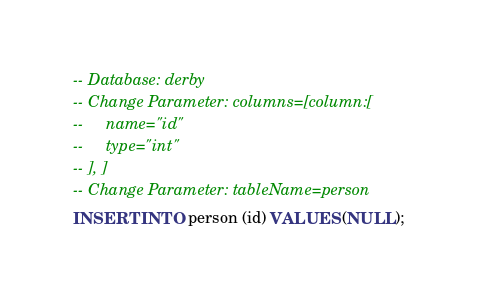Convert code to text. <code><loc_0><loc_0><loc_500><loc_500><_SQL_>-- Database: derby
-- Change Parameter: columns=[column:[
--     name="id"
--     type="int"
-- ], ]
-- Change Parameter: tableName=person
INSERT INTO person (id) VALUES (NULL);
</code> 